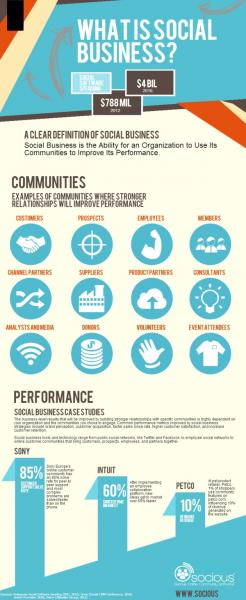Outline some significant characteristics in this image. The eleventh community listed in the infographic is volunteers. The fourth community listed in the infographic is "Members," and it is the fourth community listed in the infographic. The fifth community listed in the infographic is "Suppliers. 